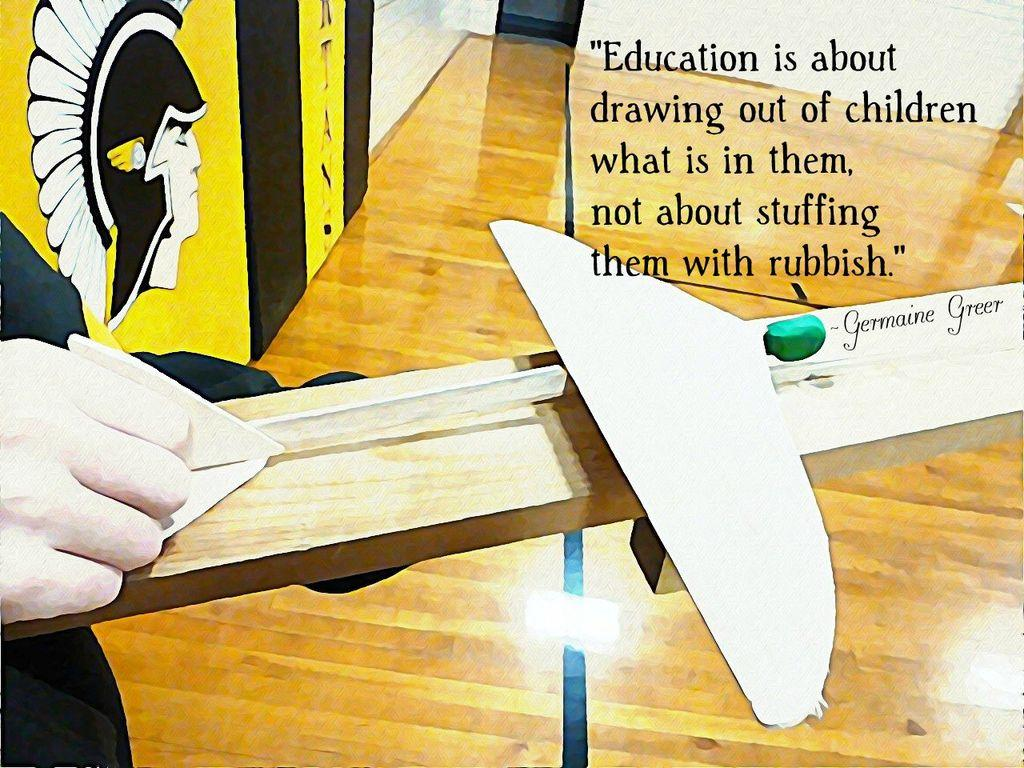<image>
Share a concise interpretation of the image provided. a picture with a quote about education and children on it 